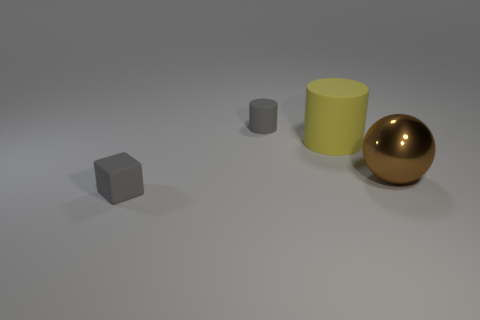What number of gray things are made of the same material as the big yellow cylinder? There are two gray objects that appear to be made of the same matte material as the large yellow cylinder. 